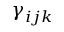<formula> <loc_0><loc_0><loc_500><loc_500>\gamma _ { i j k }</formula> 